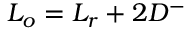Convert formula to latex. <formula><loc_0><loc_0><loc_500><loc_500>L _ { o } = L _ { r } + 2 D ^ { - }</formula> 